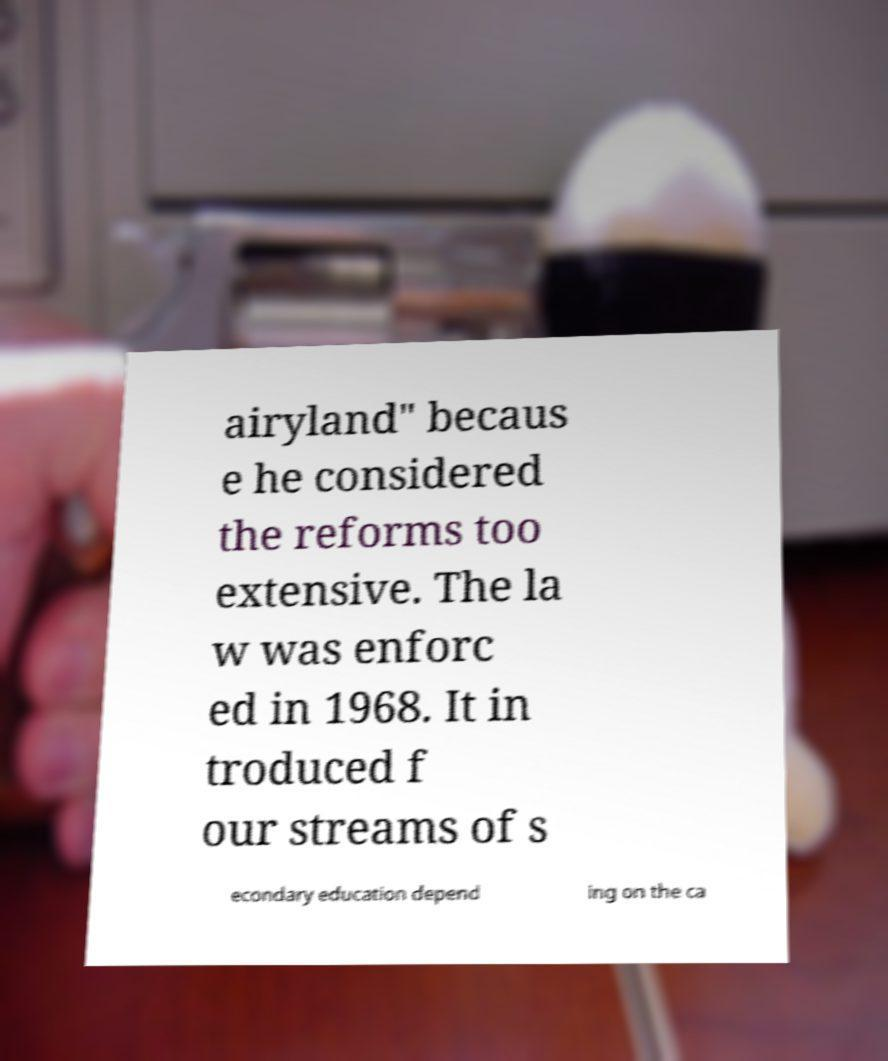Can you read and provide the text displayed in the image?This photo seems to have some interesting text. Can you extract and type it out for me? airyland" becaus e he considered the reforms too extensive. The la w was enforc ed in 1968. It in troduced f our streams of s econdary education depend ing on the ca 